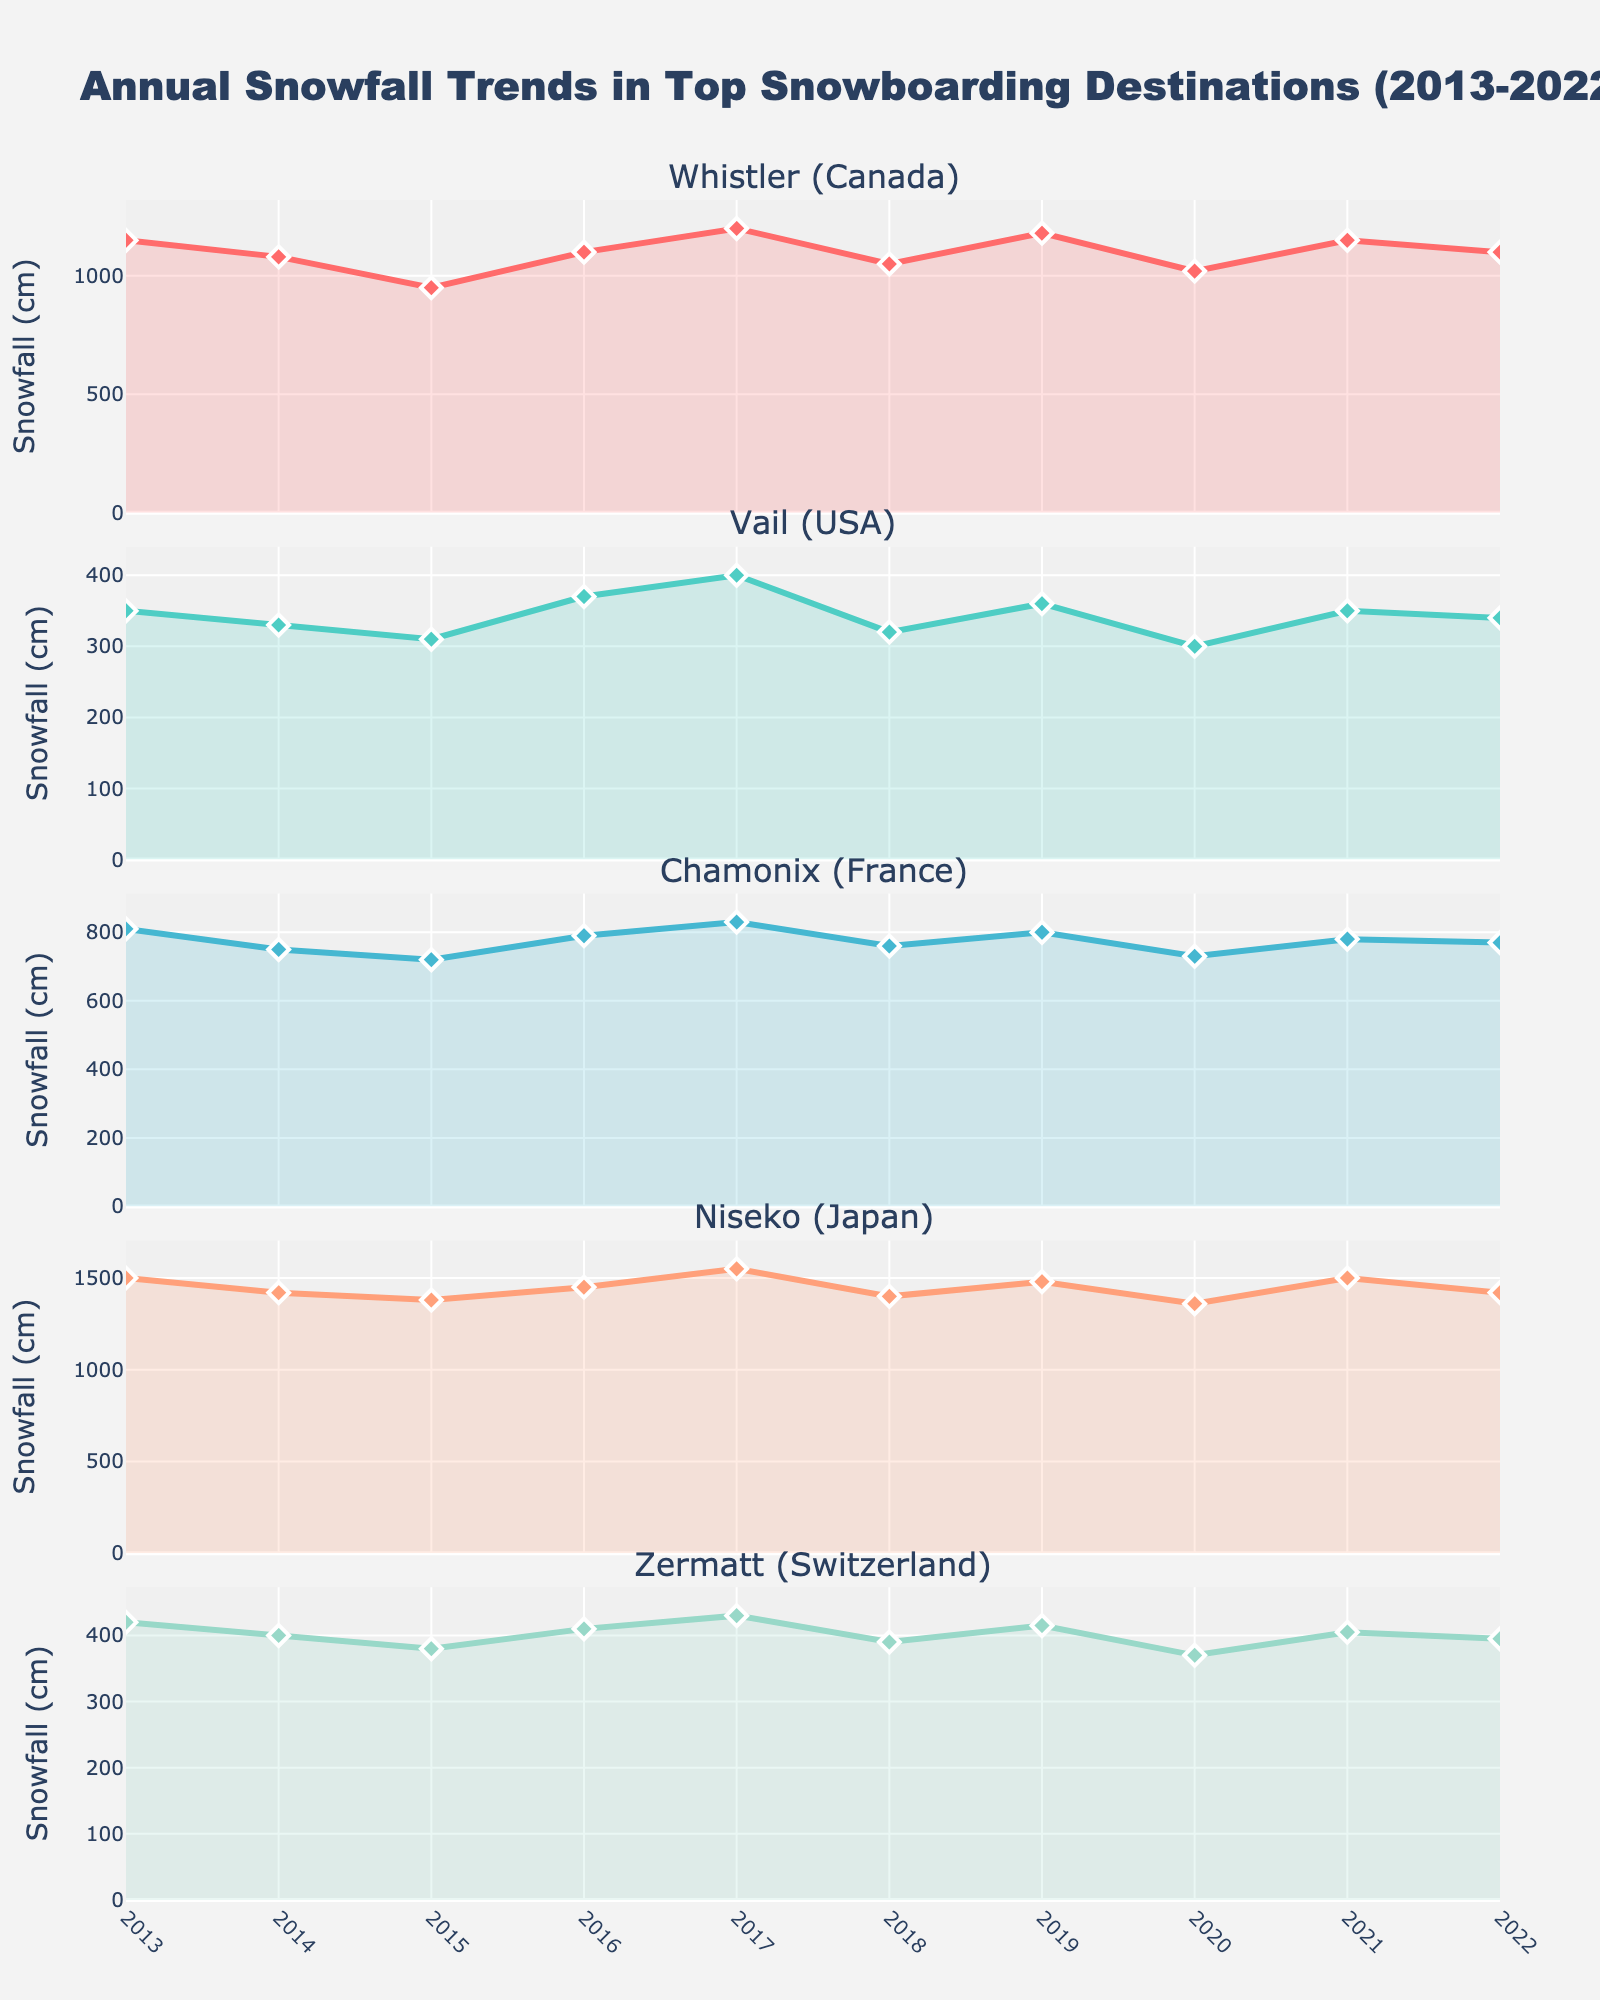what's the title of the figure? The title is usually placed at the top of the figure. It gives an overview of what the figure represents. By looking at the top of the figure, we can find the title.
Answer: Annual Snowfall Trends in Top Snowboarding Destinations (2013-2022) how many locations are shown in the subplots? By scanning through the subplot titles on the y-axis, we can count the unique locations mentioned.
Answer: 5 which location received the maximum snowfall in any single year? Check all the subplots and look for the maximum data point in each. The highest value across any subplot is the maximum. In this case, scan all lines to see that Niseko (Japan) received around 1550 cm in 2017.
Answer: Niseko (Japan) in 2017 what was the minimum snowfall recorded in Whistler (Canada) over the years? Analyze the Whistler (Canada) plot and find the lowest point in the line chart.
Answer: 950 cm in 2015 which two locations had an increase in snowfall from 2021 to 2022? For each location, compare the data points of 2021 and 2022 to see if they have increased.
Answer: Vail (USA) and Zermatt (Switzerland) what is the average snowfall in Chamonix (France) from 2013 to 2022? Sum all the snowfall values for Chamonix (France) across the years and divide by the number of years (10). 
(810 + 750 + 720 + 790 + 830 + 760 + 800 + 730 + 780 + 770) / 10 = 774
Answer: 774 cm in which year did Zermatt (Switzerland) experience its highest snowfall? Check the Zermatt (Switzerland) subplot and find the peak value and its corresponding year.
Answer: 2017 how did the snowfall trend in Niseko (Japan) change from 2013 to 2022? Look at the line chart for Niseko (Japan) and describe the pattern of highs and lows over the years. There were fluctuations with peaks in 2013 and 2017 and a general high trend over the years.
Answer: Fluctuating with peaks in 2013 and 2017 